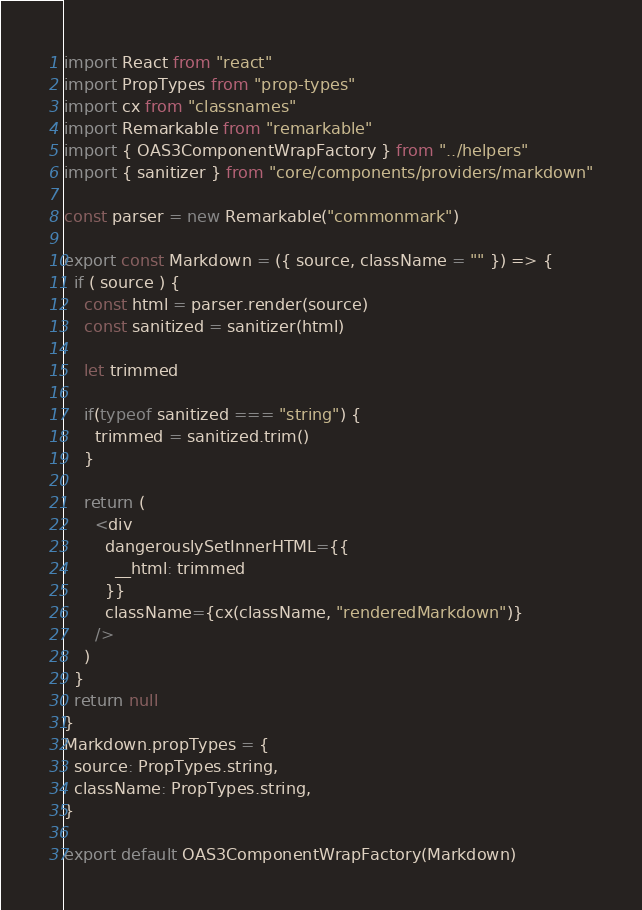<code> <loc_0><loc_0><loc_500><loc_500><_JavaScript_>import React from "react"
import PropTypes from "prop-types"
import cx from "classnames"
import Remarkable from "remarkable"
import { OAS3ComponentWrapFactory } from "../helpers"
import { sanitizer } from "core/components/providers/markdown"

const parser = new Remarkable("commonmark")

export const Markdown = ({ source, className = "" }) => {
  if ( source ) {
    const html = parser.render(source)
    const sanitized = sanitizer(html)

    let trimmed

    if(typeof sanitized === "string") {
      trimmed = sanitized.trim()
    }

    return (
      <div
        dangerouslySetInnerHTML={{
          __html: trimmed
        }}
        className={cx(className, "renderedMarkdown")}
      />
    )
  }
  return null
}
Markdown.propTypes = {
  source: PropTypes.string,
  className: PropTypes.string,
}

export default OAS3ComponentWrapFactory(Markdown)
</code> 